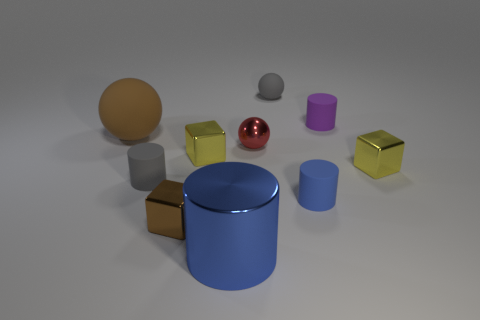What size is the blue cylinder that is made of the same material as the brown block?
Keep it short and to the point. Large. What number of other big rubber objects are the same shape as the red object?
Your answer should be compact. 1. What size is the matte thing in front of the small gray rubber cylinder that is in front of the small red sphere?
Give a very brief answer. Small. There is a red object that is the same size as the gray cylinder; what is its material?
Make the answer very short. Metal. Is there a big object made of the same material as the small purple cylinder?
Your answer should be compact. Yes. What color is the sphere behind the rubber cylinder that is behind the yellow object that is to the right of the purple object?
Make the answer very short. Gray. Do the tiny cylinder to the left of the metal sphere and the tiny ball that is behind the large matte thing have the same color?
Keep it short and to the point. Yes. Is there anything else that is the same color as the metallic cylinder?
Offer a very short reply. Yes. Is the number of large objects that are on the left side of the tiny brown metal object less than the number of big matte objects?
Your response must be concise. No. What number of tiny balls are there?
Your answer should be very brief. 2. 